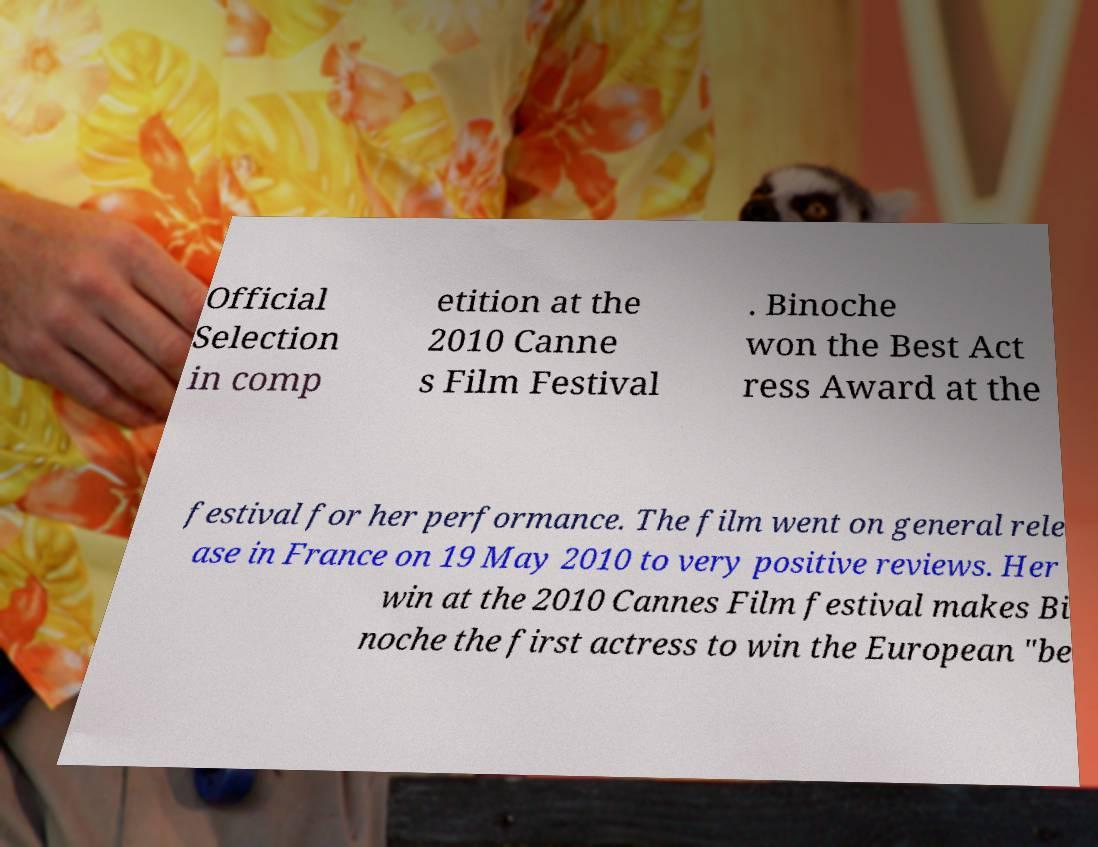There's text embedded in this image that I need extracted. Can you transcribe it verbatim? Official Selection in comp etition at the 2010 Canne s Film Festival . Binoche won the Best Act ress Award at the festival for her performance. The film went on general rele ase in France on 19 May 2010 to very positive reviews. Her win at the 2010 Cannes Film festival makes Bi noche the first actress to win the European "be 